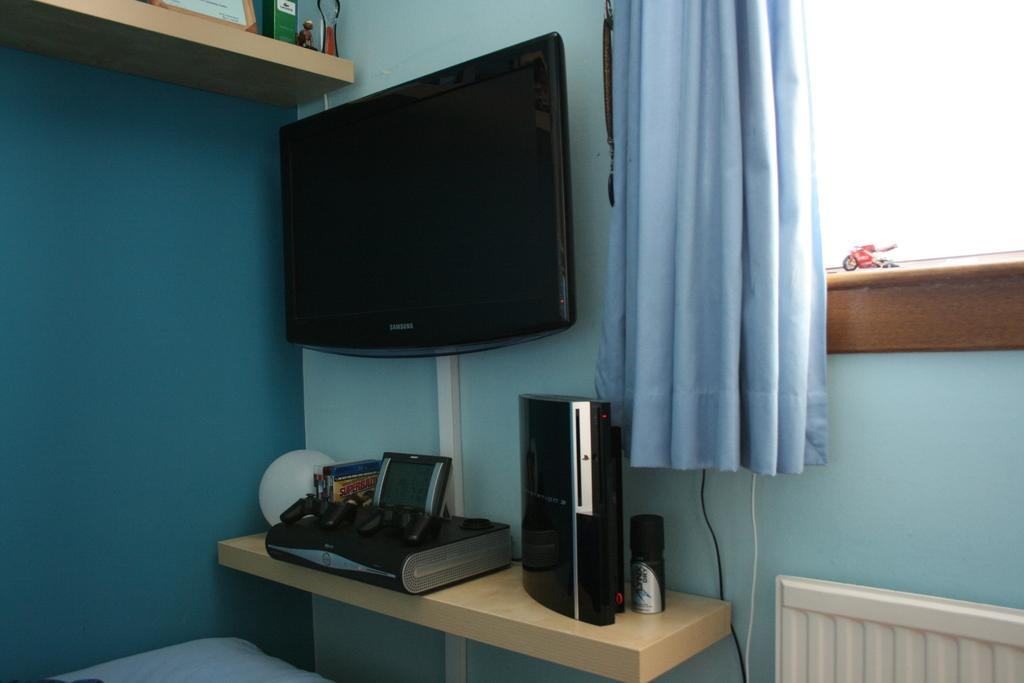What can be seen on the shelf in the image? There are electronic devices and other objects on the shelf. What type of window treatment is present in the image? There are curtains in the image. What type of object is present in the image that is typically associated with play? There is a toy in the image. What architectural feature is visible in the image that allows for natural light and a view of the outdoors? There is a window in the image. What type of wiring is visible in the image? Cable wires are visible in the image. What type of surface is present in the image that serves as a barrier between rooms or spaces? There is a wall in the image. What type of power source is visible in the image? There is no power source visible in the image. What is the purpose of the toy in the image? The purpose of the toy in the image cannot be determined from the image alone. What type of shade is present in the image? There is no shade present in the image. 